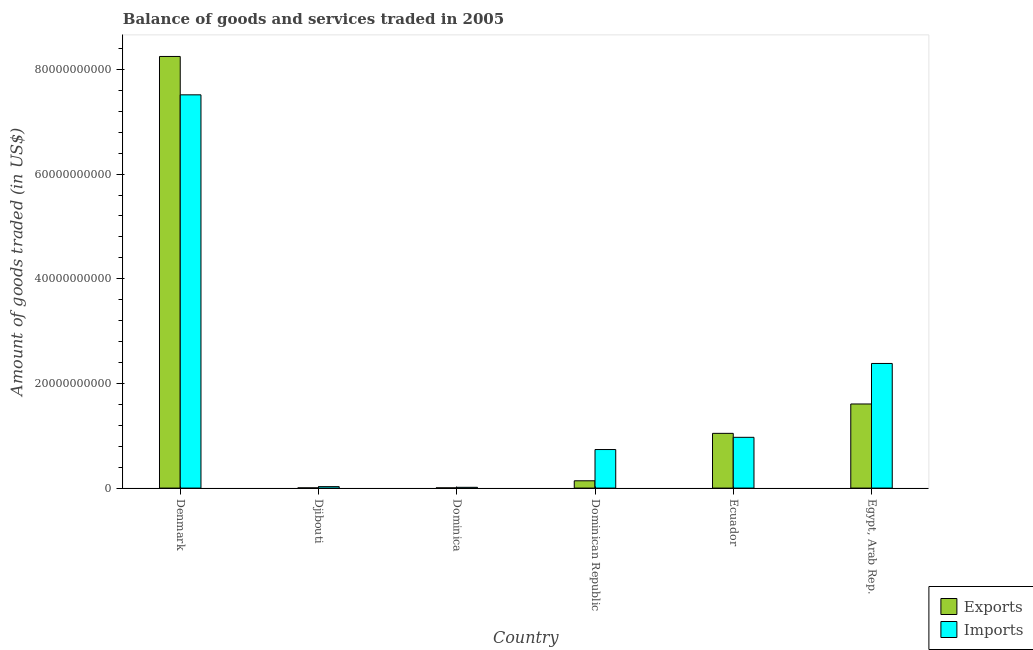Are the number of bars per tick equal to the number of legend labels?
Keep it short and to the point. Yes. How many bars are there on the 6th tick from the left?
Offer a terse response. 2. What is the label of the 5th group of bars from the left?
Ensure brevity in your answer.  Ecuador. What is the amount of goods exported in Ecuador?
Your answer should be compact. 1.05e+1. Across all countries, what is the maximum amount of goods exported?
Provide a short and direct response. 8.25e+1. Across all countries, what is the minimum amount of goods imported?
Provide a succinct answer. 1.46e+08. In which country was the amount of goods exported minimum?
Provide a succinct answer. Djibouti. What is the total amount of goods imported in the graph?
Give a very brief answer. 1.16e+11. What is the difference between the amount of goods exported in Denmark and that in Djibouti?
Provide a succinct answer. 8.24e+1. What is the difference between the amount of goods exported in Denmark and the amount of goods imported in Djibouti?
Offer a terse response. 8.22e+1. What is the average amount of goods imported per country?
Offer a very short reply. 1.94e+1. What is the difference between the amount of goods imported and amount of goods exported in Denmark?
Keep it short and to the point. -7.33e+09. What is the ratio of the amount of goods imported in Denmark to that in Dominica?
Your response must be concise. 514.98. Is the difference between the amount of goods exported in Dominica and Dominican Republic greater than the difference between the amount of goods imported in Dominica and Dominican Republic?
Offer a very short reply. Yes. What is the difference between the highest and the second highest amount of goods exported?
Your answer should be compact. 6.64e+1. What is the difference between the highest and the lowest amount of goods exported?
Ensure brevity in your answer.  8.24e+1. In how many countries, is the amount of goods imported greater than the average amount of goods imported taken over all countries?
Offer a terse response. 2. Is the sum of the amount of goods exported in Dominican Republic and Egypt, Arab Rep. greater than the maximum amount of goods imported across all countries?
Keep it short and to the point. No. What does the 2nd bar from the left in Dominican Republic represents?
Ensure brevity in your answer.  Imports. What does the 1st bar from the right in Dominican Republic represents?
Offer a terse response. Imports. How many countries are there in the graph?
Ensure brevity in your answer.  6. Does the graph contain any zero values?
Offer a very short reply. No. Does the graph contain grids?
Provide a succinct answer. No. How are the legend labels stacked?
Offer a very short reply. Vertical. What is the title of the graph?
Offer a terse response. Balance of goods and services traded in 2005. Does "Primary school" appear as one of the legend labels in the graph?
Provide a short and direct response. No. What is the label or title of the Y-axis?
Keep it short and to the point. Amount of goods traded (in US$). What is the Amount of goods traded (in US$) of Exports in Denmark?
Provide a succinct answer. 8.25e+1. What is the Amount of goods traded (in US$) in Imports in Denmark?
Provide a succinct answer. 7.52e+1. What is the Amount of goods traded (in US$) in Exports in Djibouti?
Ensure brevity in your answer.  3.95e+07. What is the Amount of goods traded (in US$) in Imports in Djibouti?
Your answer should be very brief. 2.77e+08. What is the Amount of goods traded (in US$) of Exports in Dominica?
Give a very brief answer. 4.29e+07. What is the Amount of goods traded (in US$) in Imports in Dominica?
Give a very brief answer. 1.46e+08. What is the Amount of goods traded (in US$) of Exports in Dominican Republic?
Make the answer very short. 1.40e+09. What is the Amount of goods traded (in US$) in Imports in Dominican Republic?
Ensure brevity in your answer.  7.37e+09. What is the Amount of goods traded (in US$) of Exports in Ecuador?
Provide a short and direct response. 1.05e+1. What is the Amount of goods traded (in US$) in Imports in Ecuador?
Offer a very short reply. 9.70e+09. What is the Amount of goods traded (in US$) in Exports in Egypt, Arab Rep.?
Provide a succinct answer. 1.61e+1. What is the Amount of goods traded (in US$) in Imports in Egypt, Arab Rep.?
Give a very brief answer. 2.38e+1. Across all countries, what is the maximum Amount of goods traded (in US$) in Exports?
Keep it short and to the point. 8.25e+1. Across all countries, what is the maximum Amount of goods traded (in US$) of Imports?
Your answer should be very brief. 7.52e+1. Across all countries, what is the minimum Amount of goods traded (in US$) of Exports?
Give a very brief answer. 3.95e+07. Across all countries, what is the minimum Amount of goods traded (in US$) in Imports?
Offer a terse response. 1.46e+08. What is the total Amount of goods traded (in US$) in Exports in the graph?
Your answer should be compact. 1.10e+11. What is the total Amount of goods traded (in US$) of Imports in the graph?
Your answer should be very brief. 1.16e+11. What is the difference between the Amount of goods traded (in US$) in Exports in Denmark and that in Djibouti?
Provide a short and direct response. 8.24e+1. What is the difference between the Amount of goods traded (in US$) of Imports in Denmark and that in Djibouti?
Make the answer very short. 7.49e+1. What is the difference between the Amount of goods traded (in US$) in Exports in Denmark and that in Dominica?
Give a very brief answer. 8.24e+1. What is the difference between the Amount of goods traded (in US$) in Imports in Denmark and that in Dominica?
Offer a very short reply. 7.50e+1. What is the difference between the Amount of goods traded (in US$) of Exports in Denmark and that in Dominican Republic?
Your answer should be very brief. 8.11e+1. What is the difference between the Amount of goods traded (in US$) in Imports in Denmark and that in Dominican Republic?
Give a very brief answer. 6.78e+1. What is the difference between the Amount of goods traded (in US$) in Exports in Denmark and that in Ecuador?
Give a very brief answer. 7.20e+1. What is the difference between the Amount of goods traded (in US$) in Imports in Denmark and that in Ecuador?
Offer a very short reply. 6.54e+1. What is the difference between the Amount of goods traded (in US$) of Exports in Denmark and that in Egypt, Arab Rep.?
Make the answer very short. 6.64e+1. What is the difference between the Amount of goods traded (in US$) of Imports in Denmark and that in Egypt, Arab Rep.?
Offer a terse response. 5.13e+1. What is the difference between the Amount of goods traded (in US$) of Exports in Djibouti and that in Dominica?
Your response must be concise. -3.41e+06. What is the difference between the Amount of goods traded (in US$) in Imports in Djibouti and that in Dominica?
Your answer should be compact. 1.31e+08. What is the difference between the Amount of goods traded (in US$) of Exports in Djibouti and that in Dominican Republic?
Your answer should be compact. -1.36e+09. What is the difference between the Amount of goods traded (in US$) of Imports in Djibouti and that in Dominican Republic?
Make the answer very short. -7.09e+09. What is the difference between the Amount of goods traded (in US$) of Exports in Djibouti and that in Ecuador?
Provide a short and direct response. -1.04e+1. What is the difference between the Amount of goods traded (in US$) of Imports in Djibouti and that in Ecuador?
Your answer should be very brief. -9.43e+09. What is the difference between the Amount of goods traded (in US$) in Exports in Djibouti and that in Egypt, Arab Rep.?
Make the answer very short. -1.60e+1. What is the difference between the Amount of goods traded (in US$) of Imports in Djibouti and that in Egypt, Arab Rep.?
Keep it short and to the point. -2.35e+1. What is the difference between the Amount of goods traded (in US$) in Exports in Dominica and that in Dominican Republic?
Your answer should be very brief. -1.35e+09. What is the difference between the Amount of goods traded (in US$) in Imports in Dominica and that in Dominican Republic?
Provide a short and direct response. -7.22e+09. What is the difference between the Amount of goods traded (in US$) of Exports in Dominica and that in Ecuador?
Keep it short and to the point. -1.04e+1. What is the difference between the Amount of goods traded (in US$) of Imports in Dominica and that in Ecuador?
Provide a short and direct response. -9.56e+09. What is the difference between the Amount of goods traded (in US$) of Exports in Dominica and that in Egypt, Arab Rep.?
Provide a short and direct response. -1.60e+1. What is the difference between the Amount of goods traded (in US$) of Imports in Dominica and that in Egypt, Arab Rep.?
Make the answer very short. -2.37e+1. What is the difference between the Amount of goods traded (in US$) of Exports in Dominican Republic and that in Ecuador?
Offer a terse response. -9.07e+09. What is the difference between the Amount of goods traded (in US$) in Imports in Dominican Republic and that in Ecuador?
Your answer should be compact. -2.34e+09. What is the difference between the Amount of goods traded (in US$) in Exports in Dominican Republic and that in Egypt, Arab Rep.?
Ensure brevity in your answer.  -1.47e+1. What is the difference between the Amount of goods traded (in US$) in Imports in Dominican Republic and that in Egypt, Arab Rep.?
Your answer should be very brief. -1.65e+1. What is the difference between the Amount of goods traded (in US$) in Exports in Ecuador and that in Egypt, Arab Rep.?
Your answer should be compact. -5.61e+09. What is the difference between the Amount of goods traded (in US$) of Imports in Ecuador and that in Egypt, Arab Rep.?
Your answer should be compact. -1.41e+1. What is the difference between the Amount of goods traded (in US$) in Exports in Denmark and the Amount of goods traded (in US$) in Imports in Djibouti?
Offer a terse response. 8.22e+1. What is the difference between the Amount of goods traded (in US$) of Exports in Denmark and the Amount of goods traded (in US$) of Imports in Dominica?
Provide a succinct answer. 8.23e+1. What is the difference between the Amount of goods traded (in US$) in Exports in Denmark and the Amount of goods traded (in US$) in Imports in Dominican Republic?
Make the answer very short. 7.51e+1. What is the difference between the Amount of goods traded (in US$) in Exports in Denmark and the Amount of goods traded (in US$) in Imports in Ecuador?
Keep it short and to the point. 7.28e+1. What is the difference between the Amount of goods traded (in US$) of Exports in Denmark and the Amount of goods traded (in US$) of Imports in Egypt, Arab Rep.?
Your answer should be compact. 5.87e+1. What is the difference between the Amount of goods traded (in US$) in Exports in Djibouti and the Amount of goods traded (in US$) in Imports in Dominica?
Your answer should be compact. -1.06e+08. What is the difference between the Amount of goods traded (in US$) in Exports in Djibouti and the Amount of goods traded (in US$) in Imports in Dominican Republic?
Offer a very short reply. -7.33e+09. What is the difference between the Amount of goods traded (in US$) in Exports in Djibouti and the Amount of goods traded (in US$) in Imports in Ecuador?
Keep it short and to the point. -9.66e+09. What is the difference between the Amount of goods traded (in US$) of Exports in Djibouti and the Amount of goods traded (in US$) of Imports in Egypt, Arab Rep.?
Your answer should be very brief. -2.38e+1. What is the difference between the Amount of goods traded (in US$) in Exports in Dominica and the Amount of goods traded (in US$) in Imports in Dominican Republic?
Your answer should be very brief. -7.32e+09. What is the difference between the Amount of goods traded (in US$) in Exports in Dominica and the Amount of goods traded (in US$) in Imports in Ecuador?
Offer a very short reply. -9.66e+09. What is the difference between the Amount of goods traded (in US$) in Exports in Dominica and the Amount of goods traded (in US$) in Imports in Egypt, Arab Rep.?
Make the answer very short. -2.38e+1. What is the difference between the Amount of goods traded (in US$) of Exports in Dominican Republic and the Amount of goods traded (in US$) of Imports in Ecuador?
Provide a succinct answer. -8.31e+09. What is the difference between the Amount of goods traded (in US$) in Exports in Dominican Republic and the Amount of goods traded (in US$) in Imports in Egypt, Arab Rep.?
Provide a succinct answer. -2.24e+1. What is the difference between the Amount of goods traded (in US$) in Exports in Ecuador and the Amount of goods traded (in US$) in Imports in Egypt, Arab Rep.?
Your answer should be compact. -1.34e+1. What is the average Amount of goods traded (in US$) of Exports per country?
Provide a short and direct response. 1.84e+1. What is the average Amount of goods traded (in US$) of Imports per country?
Your answer should be compact. 1.94e+1. What is the difference between the Amount of goods traded (in US$) of Exports and Amount of goods traded (in US$) of Imports in Denmark?
Give a very brief answer. 7.33e+09. What is the difference between the Amount of goods traded (in US$) in Exports and Amount of goods traded (in US$) in Imports in Djibouti?
Ensure brevity in your answer.  -2.38e+08. What is the difference between the Amount of goods traded (in US$) of Exports and Amount of goods traded (in US$) of Imports in Dominica?
Give a very brief answer. -1.03e+08. What is the difference between the Amount of goods traded (in US$) in Exports and Amount of goods traded (in US$) in Imports in Dominican Republic?
Your answer should be very brief. -5.97e+09. What is the difference between the Amount of goods traded (in US$) of Exports and Amount of goods traded (in US$) of Imports in Ecuador?
Give a very brief answer. 7.58e+08. What is the difference between the Amount of goods traded (in US$) in Exports and Amount of goods traded (in US$) in Imports in Egypt, Arab Rep.?
Ensure brevity in your answer.  -7.74e+09. What is the ratio of the Amount of goods traded (in US$) of Exports in Denmark to that in Djibouti?
Give a very brief answer. 2088.24. What is the ratio of the Amount of goods traded (in US$) in Imports in Denmark to that in Djibouti?
Ensure brevity in your answer.  271. What is the ratio of the Amount of goods traded (in US$) in Exports in Denmark to that in Dominica?
Offer a terse response. 1922.34. What is the ratio of the Amount of goods traded (in US$) in Imports in Denmark to that in Dominica?
Your answer should be very brief. 514.98. What is the ratio of the Amount of goods traded (in US$) of Exports in Denmark to that in Dominican Republic?
Provide a short and direct response. 59.13. What is the ratio of the Amount of goods traded (in US$) in Imports in Denmark to that in Dominican Republic?
Your answer should be very brief. 10.2. What is the ratio of the Amount of goods traded (in US$) in Exports in Denmark to that in Ecuador?
Your answer should be compact. 7.88. What is the ratio of the Amount of goods traded (in US$) in Imports in Denmark to that in Ecuador?
Ensure brevity in your answer.  7.75. What is the ratio of the Amount of goods traded (in US$) in Exports in Denmark to that in Egypt, Arab Rep.?
Your response must be concise. 5.13. What is the ratio of the Amount of goods traded (in US$) of Imports in Denmark to that in Egypt, Arab Rep.?
Provide a succinct answer. 3.16. What is the ratio of the Amount of goods traded (in US$) of Exports in Djibouti to that in Dominica?
Provide a short and direct response. 0.92. What is the ratio of the Amount of goods traded (in US$) of Imports in Djibouti to that in Dominica?
Offer a terse response. 1.9. What is the ratio of the Amount of goods traded (in US$) of Exports in Djibouti to that in Dominican Republic?
Ensure brevity in your answer.  0.03. What is the ratio of the Amount of goods traded (in US$) of Imports in Djibouti to that in Dominican Republic?
Provide a succinct answer. 0.04. What is the ratio of the Amount of goods traded (in US$) of Exports in Djibouti to that in Ecuador?
Offer a terse response. 0. What is the ratio of the Amount of goods traded (in US$) in Imports in Djibouti to that in Ecuador?
Provide a succinct answer. 0.03. What is the ratio of the Amount of goods traded (in US$) of Exports in Djibouti to that in Egypt, Arab Rep.?
Your response must be concise. 0. What is the ratio of the Amount of goods traded (in US$) in Imports in Djibouti to that in Egypt, Arab Rep.?
Provide a short and direct response. 0.01. What is the ratio of the Amount of goods traded (in US$) of Exports in Dominica to that in Dominican Republic?
Your answer should be very brief. 0.03. What is the ratio of the Amount of goods traded (in US$) in Imports in Dominica to that in Dominican Republic?
Your answer should be compact. 0.02. What is the ratio of the Amount of goods traded (in US$) in Exports in Dominica to that in Ecuador?
Offer a terse response. 0. What is the ratio of the Amount of goods traded (in US$) of Imports in Dominica to that in Ecuador?
Keep it short and to the point. 0.01. What is the ratio of the Amount of goods traded (in US$) in Exports in Dominica to that in Egypt, Arab Rep.?
Give a very brief answer. 0. What is the ratio of the Amount of goods traded (in US$) in Imports in Dominica to that in Egypt, Arab Rep.?
Provide a short and direct response. 0.01. What is the ratio of the Amount of goods traded (in US$) in Exports in Dominican Republic to that in Ecuador?
Offer a terse response. 0.13. What is the ratio of the Amount of goods traded (in US$) of Imports in Dominican Republic to that in Ecuador?
Offer a very short reply. 0.76. What is the ratio of the Amount of goods traded (in US$) of Exports in Dominican Republic to that in Egypt, Arab Rep.?
Your response must be concise. 0.09. What is the ratio of the Amount of goods traded (in US$) in Imports in Dominican Republic to that in Egypt, Arab Rep.?
Your response must be concise. 0.31. What is the ratio of the Amount of goods traded (in US$) in Exports in Ecuador to that in Egypt, Arab Rep.?
Offer a terse response. 0.65. What is the ratio of the Amount of goods traded (in US$) in Imports in Ecuador to that in Egypt, Arab Rep.?
Keep it short and to the point. 0.41. What is the difference between the highest and the second highest Amount of goods traded (in US$) in Exports?
Your answer should be compact. 6.64e+1. What is the difference between the highest and the second highest Amount of goods traded (in US$) of Imports?
Ensure brevity in your answer.  5.13e+1. What is the difference between the highest and the lowest Amount of goods traded (in US$) in Exports?
Keep it short and to the point. 8.24e+1. What is the difference between the highest and the lowest Amount of goods traded (in US$) in Imports?
Your response must be concise. 7.50e+1. 